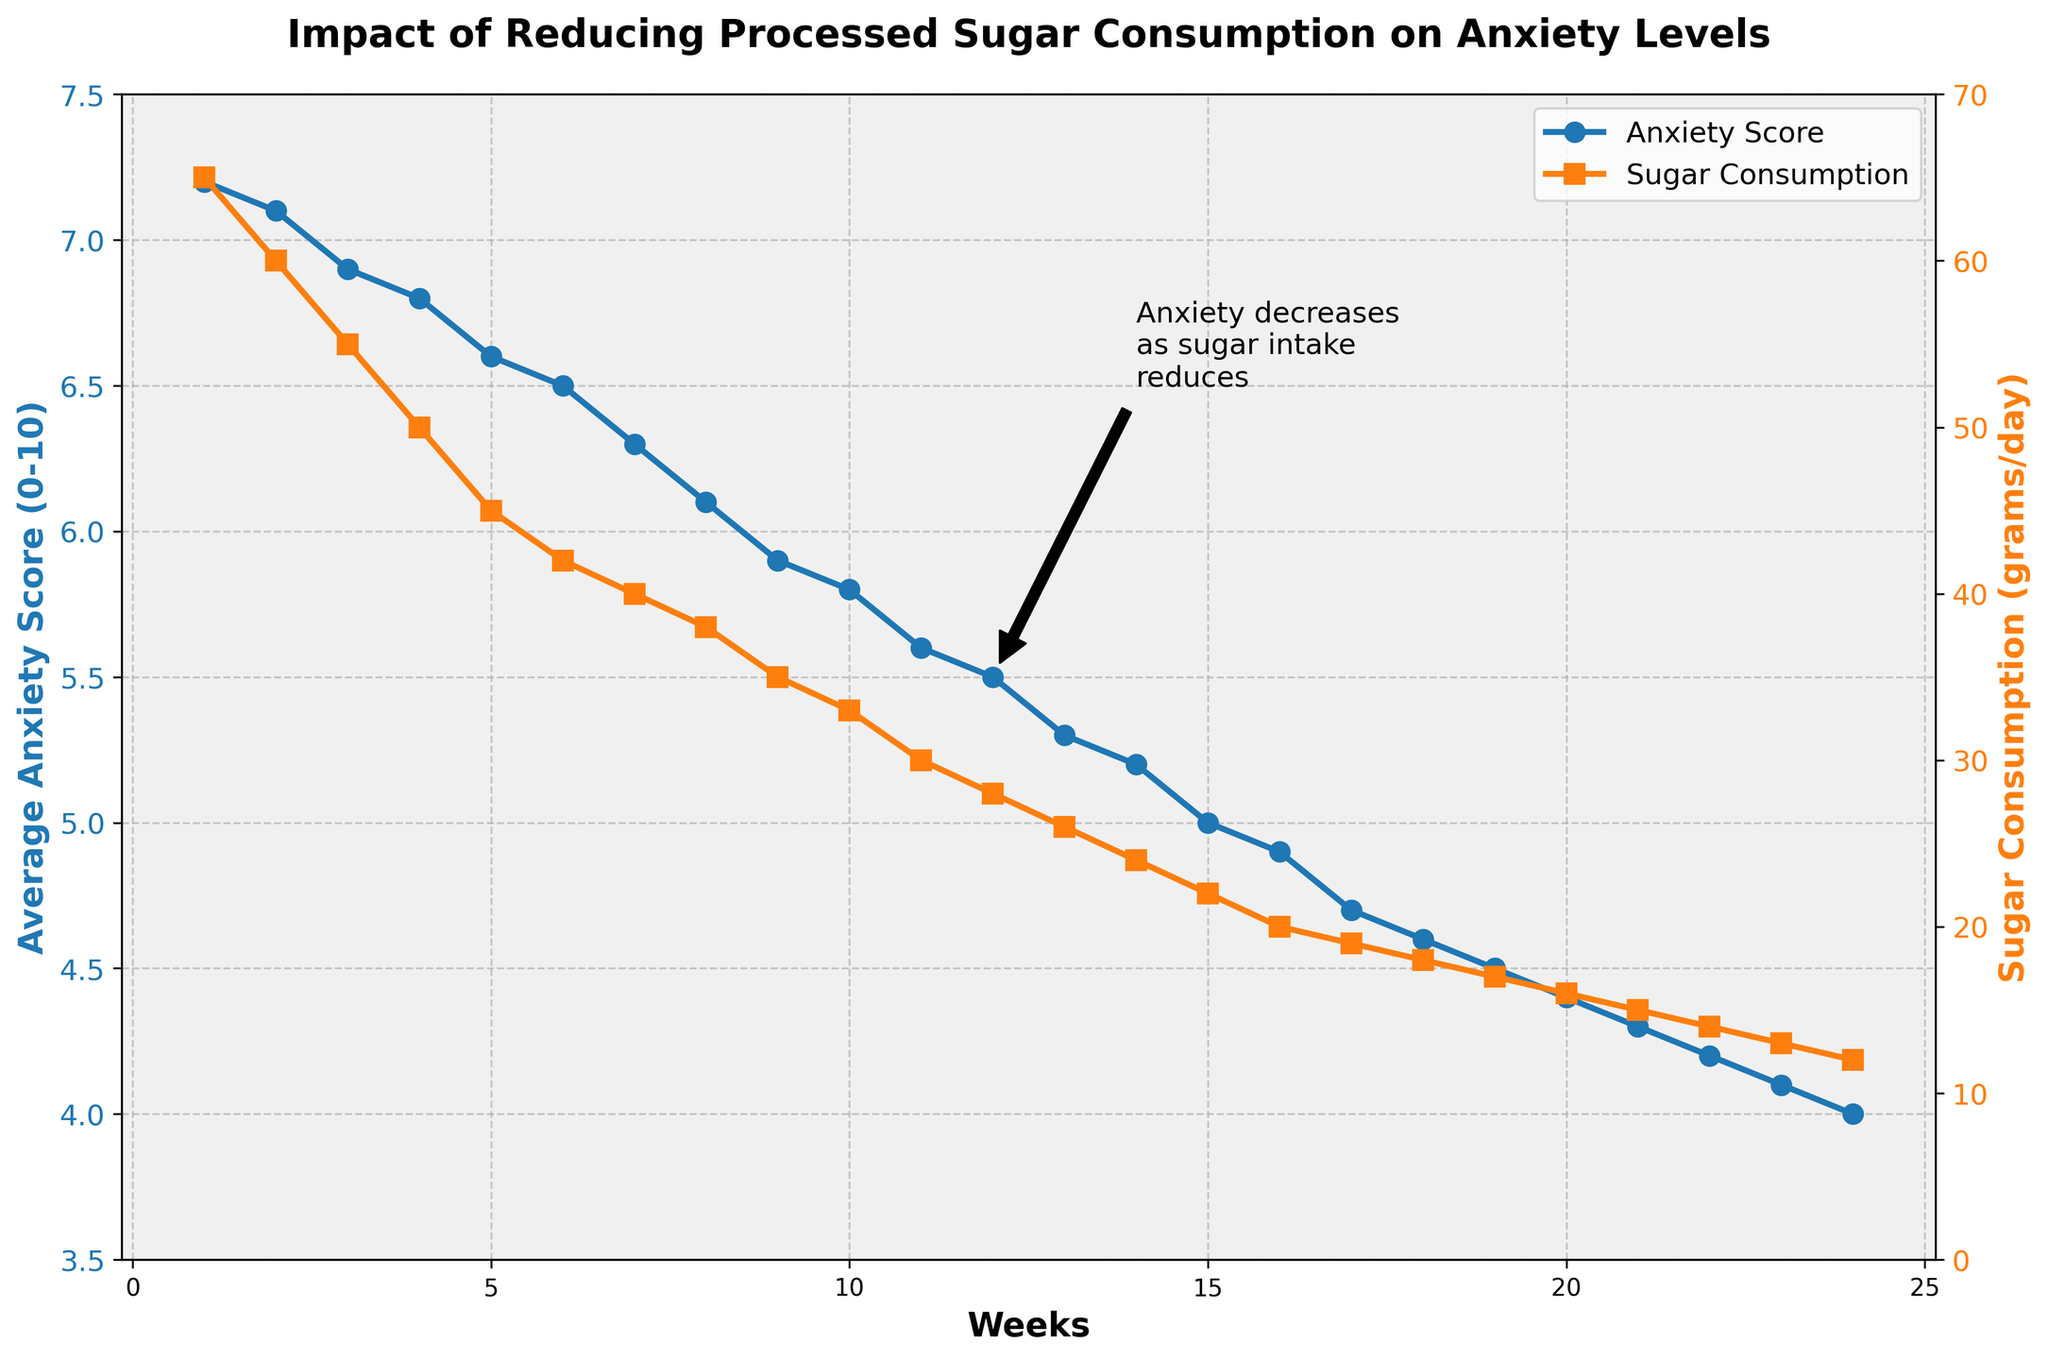Which week has the highest anxiety score? To answer this, look for the highest point on the line representing anxiety scores. According to the plot, the highest anxiety score occurs in Week 1 at 7.2.
Answer: Week 1 By how much did the anxiety score decrease between Week 1 and Week 24? The anxiety score in Week 1 is 7.2 and in Week 24 it is 4.0. The decrease is calculated as 7.2 - 4.0 = 3.2.
Answer: 3.2 Is there a point where the anxiety score drops more than 0.5 in a week? To find this, examine the weekly changes in the anxiety scores. The largest decrease occurs between Week 8 (6.1) and Week 9 (5.9), which is 6.1 - 5.9 = 0.2, hence no single week shows a drop greater than 0.5.
Answer: No Describe the relationship between sugar consumption and anxiety scores over the 24 weeks? The plot shows a decrease in both sugar consumption and anxiety scores, indicating an inverse relationship. As sugar consumption decreases, anxiety scores also trend downward.
Answer: Inverse relationship What was the sugar consumption level when the anxiety score first fell below 5.0? According to the plot, the anxiety score first falls below 5.0 in Week 15. The sugar consumption at this point is 22 grams per day.
Answer: 22 grams/day What trend do you observe in sugar consumption from Week 1 to Week 24? The plot shows a steady decline in sugar consumption from Week 1 to Week 24, starting at 65 grams/day and ending at 12 grams/day.
Answer: Steady decline How does the average anxiety score in the first six weeks compare to the last six weeks? Calculate the average for Weeks 1-6 and Weeks 19-24. First 6-week average: (7.2 + 7.1 + 6.9 + 6.8 + 6.6 + 6.5)/6 = 6.85. Last 6-week average: (4.5 + 4.4 + 4.3 + 4.2 + 4.1 + 4.0)/6 = 4.25. Comparison shows the last six weeks have a significantly lower average anxiety score.
Answer: Last six weeks lower What does the annotation on the plot indicate? The annotation notes that anxiety decreases as sugar intake reduces, highlighting a key insight from the data. It is positioned around Week 12 and refers to visible trends in the plot.
Answer: Anxiety decreases with sugar reduction Compare the sugar consumption at Week 12 and Week 24. The plot shows sugar consumption at 28 grams/day in Week 12 and 12 grams/day in Week 24. The decrease is 28 - 12 = 16 grams/day.
Answer: 16 grams/day decrease When did the most significant visual dip in anxiety score occur? The most significant visual dip occurs between Weeks 12 to 13, where the anxiety score drops from 5.5 to 5.3, showing a noticeable decline on the plot.
Answer: Weeks 12 to 13 